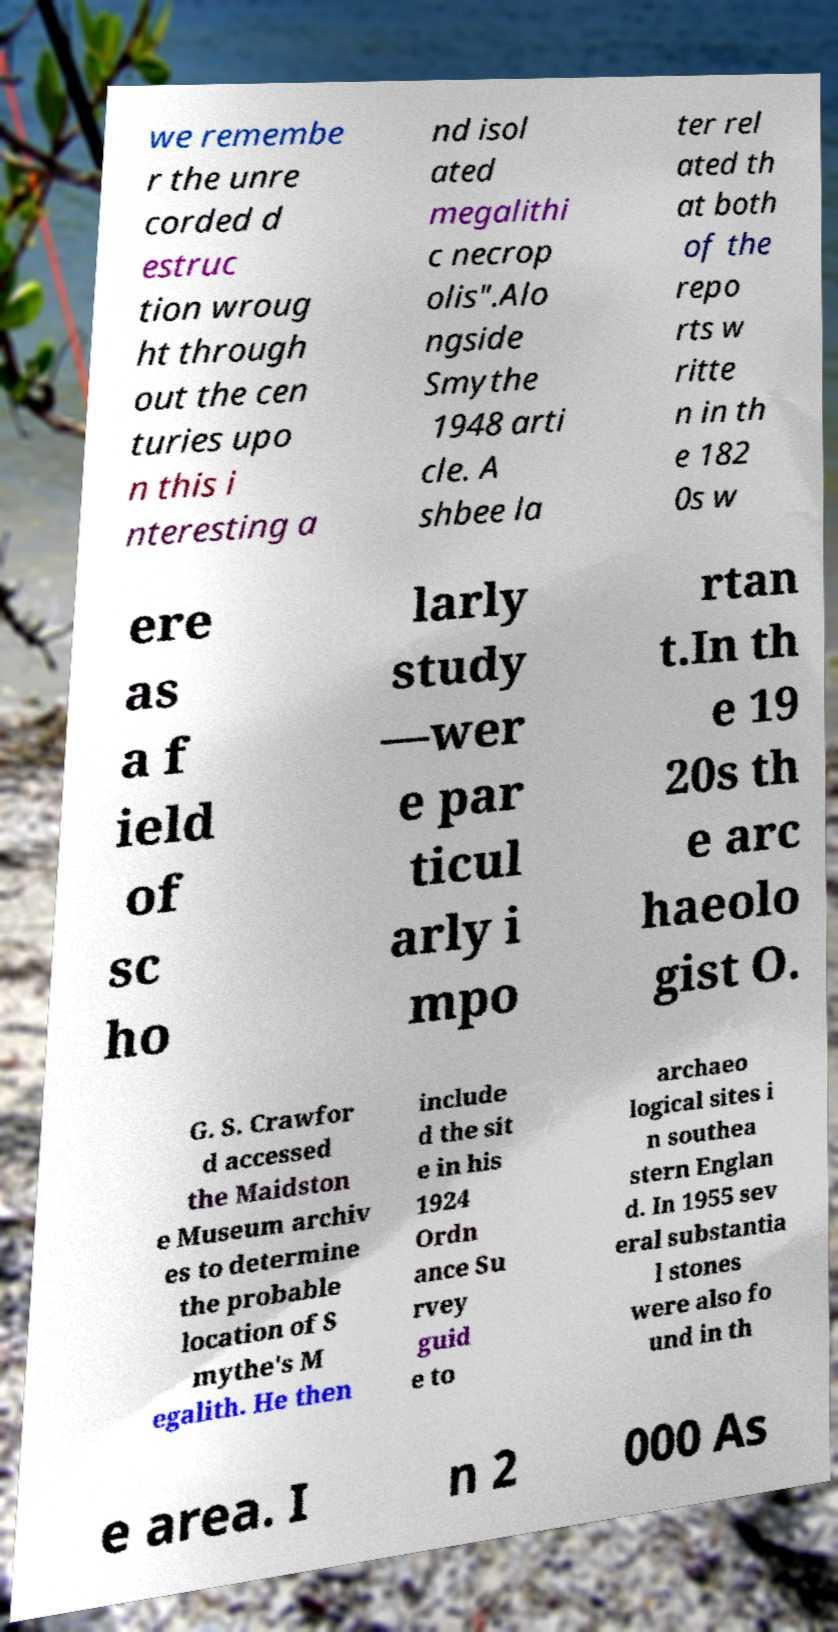What messages or text are displayed in this image? I need them in a readable, typed format. we remembe r the unre corded d estruc tion wroug ht through out the cen turies upo n this i nteresting a nd isol ated megalithi c necrop olis".Alo ngside Smythe 1948 arti cle. A shbee la ter rel ated th at both of the repo rts w ritte n in th e 182 0s w ere as a f ield of sc ho larly study —wer e par ticul arly i mpo rtan t.In th e 19 20s th e arc haeolo gist O. G. S. Crawfor d accessed the Maidston e Museum archiv es to determine the probable location of S mythe's M egalith. He then include d the sit e in his 1924 Ordn ance Su rvey guid e to archaeo logical sites i n southea stern Englan d. In 1955 sev eral substantia l stones were also fo und in th e area. I n 2 000 As 